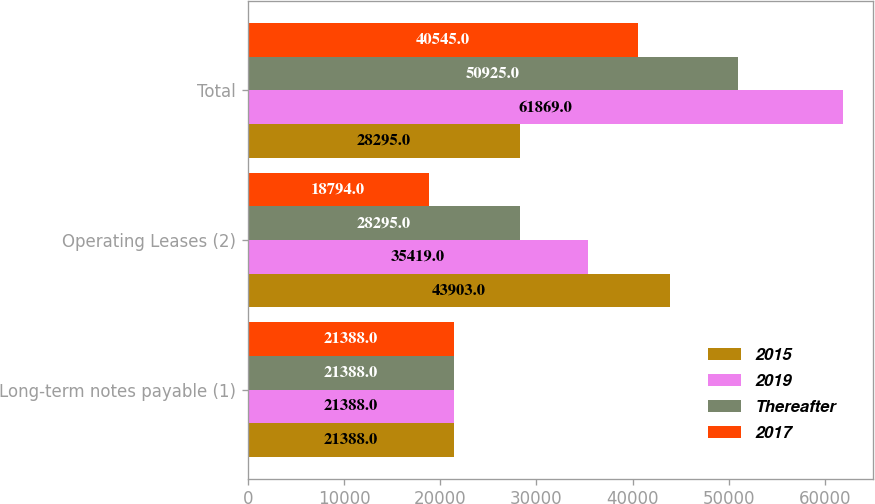<chart> <loc_0><loc_0><loc_500><loc_500><stacked_bar_chart><ecel><fcel>Long-term notes payable (1)<fcel>Operating Leases (2)<fcel>Total<nl><fcel>2015<fcel>21388<fcel>43903<fcel>28295<nl><fcel>2019<fcel>21388<fcel>35419<fcel>61869<nl><fcel>Thereafter<fcel>21388<fcel>28295<fcel>50925<nl><fcel>2017<fcel>21388<fcel>18794<fcel>40545<nl></chart> 